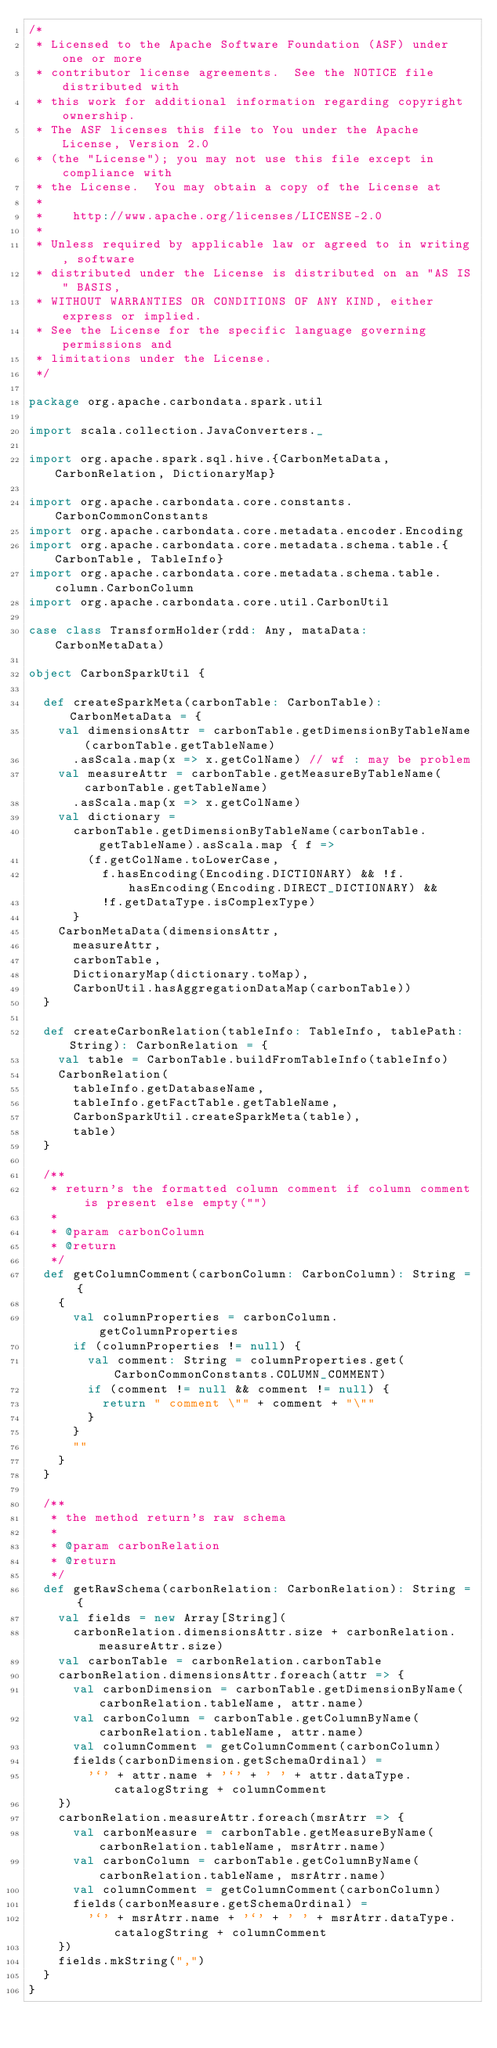<code> <loc_0><loc_0><loc_500><loc_500><_Scala_>/*
 * Licensed to the Apache Software Foundation (ASF) under one or more
 * contributor license agreements.  See the NOTICE file distributed with
 * this work for additional information regarding copyright ownership.
 * The ASF licenses this file to You under the Apache License, Version 2.0
 * (the "License"); you may not use this file except in compliance with
 * the License.  You may obtain a copy of the License at
 *
 *    http://www.apache.org/licenses/LICENSE-2.0
 *
 * Unless required by applicable law or agreed to in writing, software
 * distributed under the License is distributed on an "AS IS" BASIS,
 * WITHOUT WARRANTIES OR CONDITIONS OF ANY KIND, either express or implied.
 * See the License for the specific language governing permissions and
 * limitations under the License.
 */

package org.apache.carbondata.spark.util

import scala.collection.JavaConverters._

import org.apache.spark.sql.hive.{CarbonMetaData, CarbonRelation, DictionaryMap}

import org.apache.carbondata.core.constants.CarbonCommonConstants
import org.apache.carbondata.core.metadata.encoder.Encoding
import org.apache.carbondata.core.metadata.schema.table.{CarbonTable, TableInfo}
import org.apache.carbondata.core.metadata.schema.table.column.CarbonColumn
import org.apache.carbondata.core.util.CarbonUtil

case class TransformHolder(rdd: Any, mataData: CarbonMetaData)

object CarbonSparkUtil {

  def createSparkMeta(carbonTable: CarbonTable): CarbonMetaData = {
    val dimensionsAttr = carbonTable.getDimensionByTableName(carbonTable.getTableName)
      .asScala.map(x => x.getColName) // wf : may be problem
    val measureAttr = carbonTable.getMeasureByTableName(carbonTable.getTableName)
      .asScala.map(x => x.getColName)
    val dictionary =
      carbonTable.getDimensionByTableName(carbonTable.getTableName).asScala.map { f =>
        (f.getColName.toLowerCase,
          f.hasEncoding(Encoding.DICTIONARY) && !f.hasEncoding(Encoding.DIRECT_DICTIONARY) &&
          !f.getDataType.isComplexType)
      }
    CarbonMetaData(dimensionsAttr,
      measureAttr,
      carbonTable,
      DictionaryMap(dictionary.toMap),
      CarbonUtil.hasAggregationDataMap(carbonTable))
  }

  def createCarbonRelation(tableInfo: TableInfo, tablePath: String): CarbonRelation = {
    val table = CarbonTable.buildFromTableInfo(tableInfo)
    CarbonRelation(
      tableInfo.getDatabaseName,
      tableInfo.getFactTable.getTableName,
      CarbonSparkUtil.createSparkMeta(table),
      table)
  }

  /**
   * return's the formatted column comment if column comment is present else empty("")
   *
   * @param carbonColumn
   * @return
   */
  def getColumnComment(carbonColumn: CarbonColumn): String = {
    {
      val columnProperties = carbonColumn.getColumnProperties
      if (columnProperties != null) {
        val comment: String = columnProperties.get(CarbonCommonConstants.COLUMN_COMMENT)
        if (comment != null && comment != null) {
          return " comment \"" + comment + "\""
        }
      }
      ""
    }
  }

  /**
   * the method return's raw schema
   *
   * @param carbonRelation
   * @return
   */
  def getRawSchema(carbonRelation: CarbonRelation): String = {
    val fields = new Array[String](
      carbonRelation.dimensionsAttr.size + carbonRelation.measureAttr.size)
    val carbonTable = carbonRelation.carbonTable
    carbonRelation.dimensionsAttr.foreach(attr => {
      val carbonDimension = carbonTable.getDimensionByName(carbonRelation.tableName, attr.name)
      val carbonColumn = carbonTable.getColumnByName(carbonRelation.tableName, attr.name)
      val columnComment = getColumnComment(carbonColumn)
      fields(carbonDimension.getSchemaOrdinal) =
        '`' + attr.name + '`' + ' ' + attr.dataType.catalogString + columnComment
    })
    carbonRelation.measureAttr.foreach(msrAtrr => {
      val carbonMeasure = carbonTable.getMeasureByName(carbonRelation.tableName, msrAtrr.name)
      val carbonColumn = carbonTable.getColumnByName(carbonRelation.tableName, msrAtrr.name)
      val columnComment = getColumnComment(carbonColumn)
      fields(carbonMeasure.getSchemaOrdinal) =
        '`' + msrAtrr.name + '`' + ' ' + msrAtrr.dataType.catalogString + columnComment
    })
    fields.mkString(",")
  }
}
</code> 